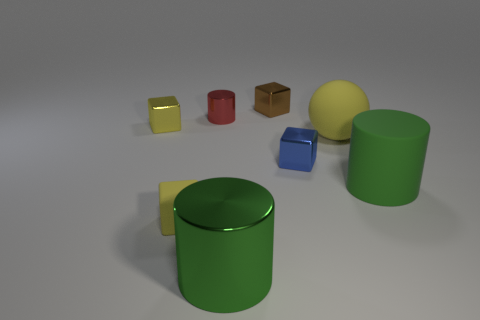How many green cylinders must be subtracted to get 1 green cylinders? 1 Subtract all tiny shiny blocks. How many blocks are left? 1 Subtract all red cylinders. How many cylinders are left? 2 Subtract 1 spheres. How many spheres are left? 0 Add 1 big rubber things. How many objects exist? 9 Subtract all balls. How many objects are left? 7 Subtract all blue cylinders. How many yellow cubes are left? 2 Subtract all small shiny things. Subtract all big green spheres. How many objects are left? 4 Add 5 small yellow cubes. How many small yellow cubes are left? 7 Add 8 large brown metallic cylinders. How many large brown metallic cylinders exist? 8 